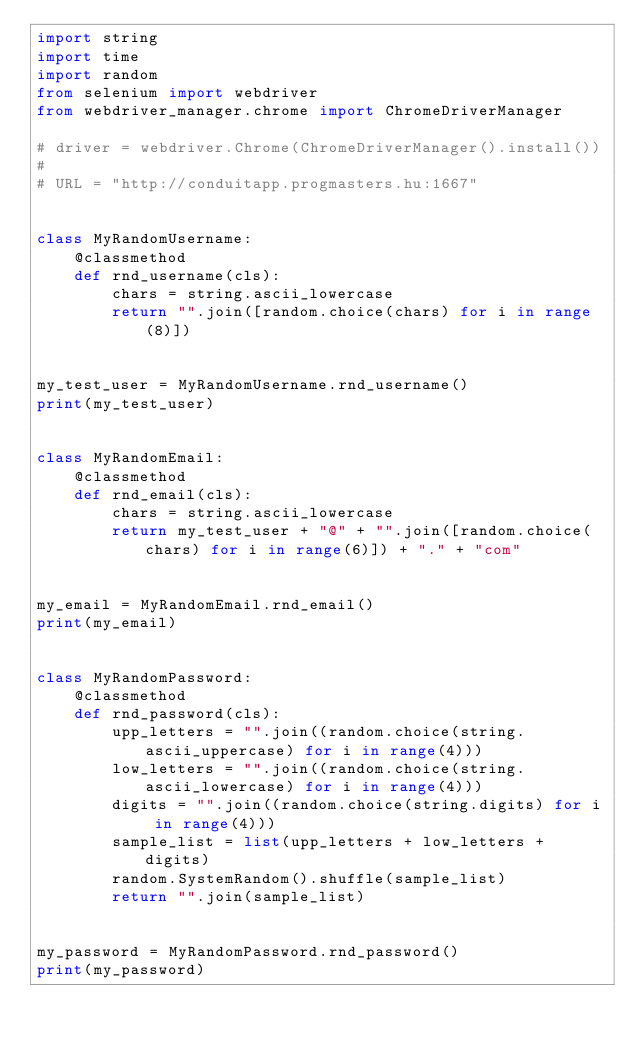Convert code to text. <code><loc_0><loc_0><loc_500><loc_500><_Python_>import string
import time
import random
from selenium import webdriver
from webdriver_manager.chrome import ChromeDriverManager

# driver = webdriver.Chrome(ChromeDriverManager().install())
#
# URL = "http://conduitapp.progmasters.hu:1667"


class MyRandomUsername:
    @classmethod
    def rnd_username(cls):
        chars = string.ascii_lowercase
        return "".join([random.choice(chars) for i in range(8)])


my_test_user = MyRandomUsername.rnd_username()
print(my_test_user)


class MyRandomEmail:
    @classmethod
    def rnd_email(cls):
        chars = string.ascii_lowercase
        return my_test_user + "@" + "".join([random.choice(chars) for i in range(6)]) + "." + "com"


my_email = MyRandomEmail.rnd_email()
print(my_email)


class MyRandomPassword:
    @classmethod
    def rnd_password(cls):
        upp_letters = "".join((random.choice(string.ascii_uppercase) for i in range(4)))
        low_letters = "".join((random.choice(string.ascii_lowercase) for i in range(4)))
        digits = "".join((random.choice(string.digits) for i in range(4)))
        sample_list = list(upp_letters + low_letters + digits)
        random.SystemRandom().shuffle(sample_list)
        return "".join(sample_list)


my_password = MyRandomPassword.rnd_password()
print(my_password)
</code> 